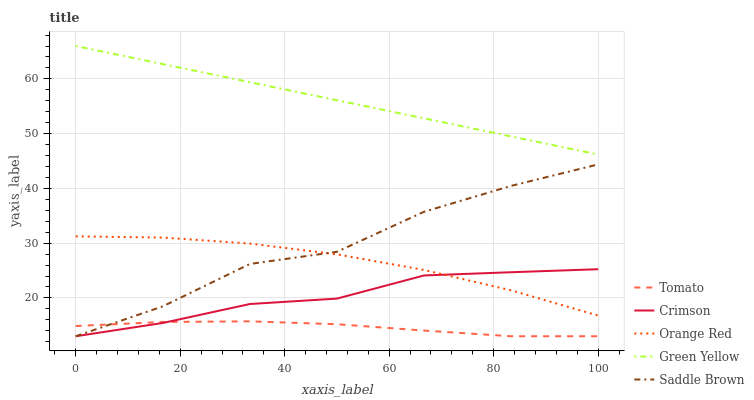Does Tomato have the minimum area under the curve?
Answer yes or no. Yes. Does Green Yellow have the maximum area under the curve?
Answer yes or no. Yes. Does Crimson have the minimum area under the curve?
Answer yes or no. No. Does Crimson have the maximum area under the curve?
Answer yes or no. No. Is Green Yellow the smoothest?
Answer yes or no. Yes. Is Saddle Brown the roughest?
Answer yes or no. Yes. Is Crimson the smoothest?
Answer yes or no. No. Is Crimson the roughest?
Answer yes or no. No. Does Green Yellow have the lowest value?
Answer yes or no. No. Does Crimson have the highest value?
Answer yes or no. No. Is Saddle Brown less than Green Yellow?
Answer yes or no. Yes. Is Green Yellow greater than Tomato?
Answer yes or no. Yes. Does Saddle Brown intersect Green Yellow?
Answer yes or no. No. 